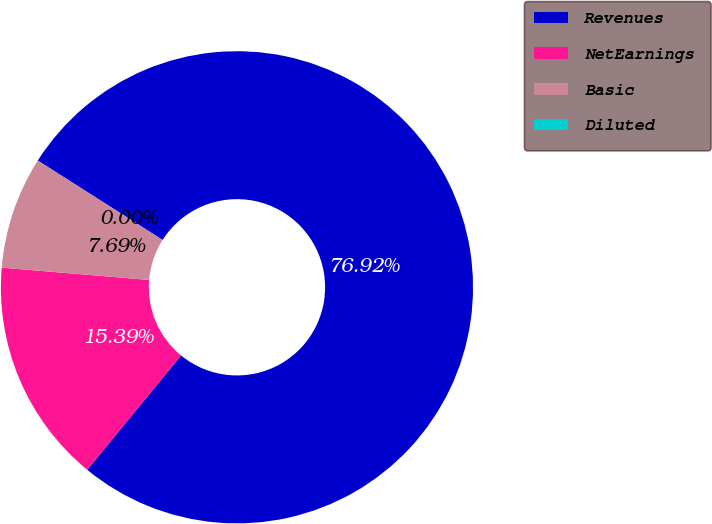Convert chart to OTSL. <chart><loc_0><loc_0><loc_500><loc_500><pie_chart><fcel>Revenues<fcel>NetEarnings<fcel>Basic<fcel>Diluted<nl><fcel>76.92%<fcel>15.39%<fcel>7.69%<fcel>0.0%<nl></chart> 